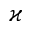Convert formula to latex. <formula><loc_0><loc_0><loc_500><loc_500>\varkappa</formula> 